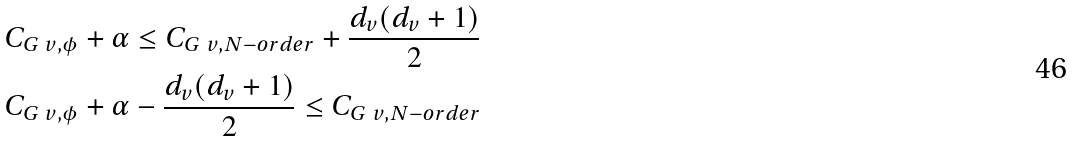<formula> <loc_0><loc_0><loc_500><loc_500>C _ { G \ v , \phi } + \alpha \leq C _ { G \ v , N - o r d e r } + \frac { d _ { v } ( d _ { v } + 1 ) } { 2 } \\ C _ { G \ v , \phi } + \alpha - \frac { d _ { v } ( d _ { v } + 1 ) } { 2 } \leq C _ { G \ v , N - o r d e r } \\</formula> 